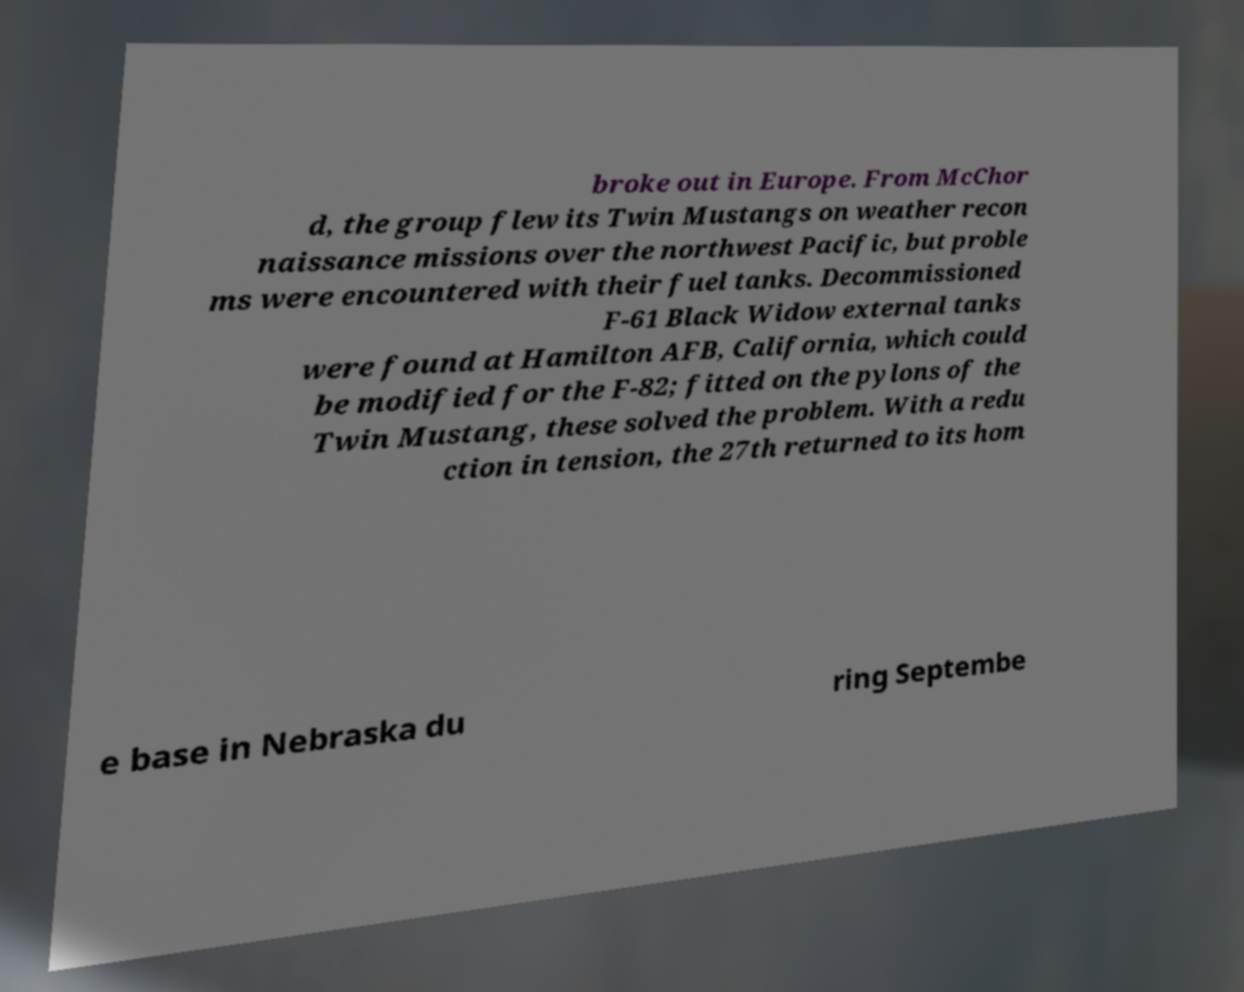I need the written content from this picture converted into text. Can you do that? broke out in Europe. From McChor d, the group flew its Twin Mustangs on weather recon naissance missions over the northwest Pacific, but proble ms were encountered with their fuel tanks. Decommissioned F-61 Black Widow external tanks were found at Hamilton AFB, California, which could be modified for the F-82; fitted on the pylons of the Twin Mustang, these solved the problem. With a redu ction in tension, the 27th returned to its hom e base in Nebraska du ring Septembe 